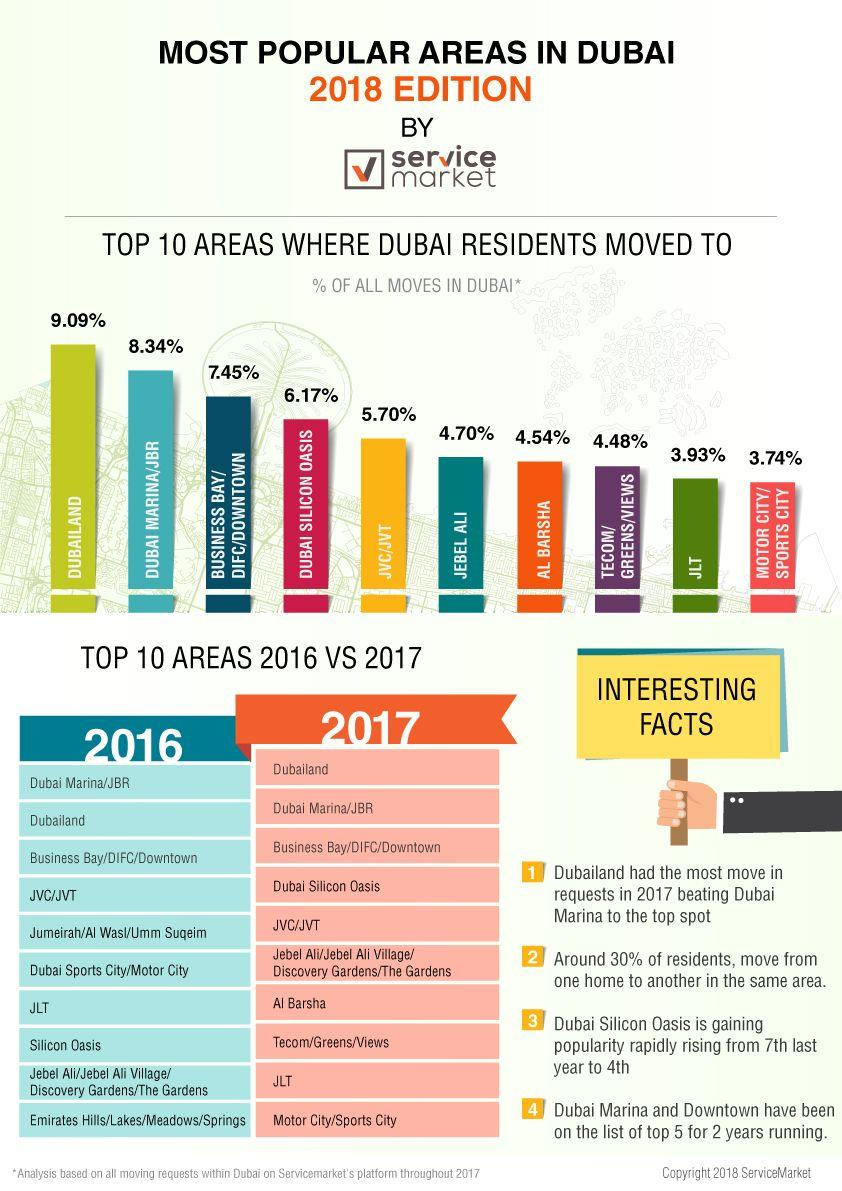Indicate a few pertinent items in this graphic. According to the table, approximately 8.34%, 5.70%, and 3.93% of residents moved to JBR. Some places in Dubai have a lower than four percent rate of move-ins, with JLT and Motor City/Sports City being among them. In 2017, JLT, a residential area, was moved two places down in the preferred list. Dubai Silicon Oasis was the fourth most preferred area of residence in Dubai, with many residents choosing to live there due to its high quality of life and convenient location. According to a survey, only 3.93% of Dubai residents preferred to stay in Jebel Ali. 